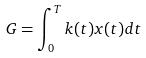<formula> <loc_0><loc_0><loc_500><loc_500>G = \int _ { 0 } ^ { T } k ( t ) x ( t ) d t</formula> 